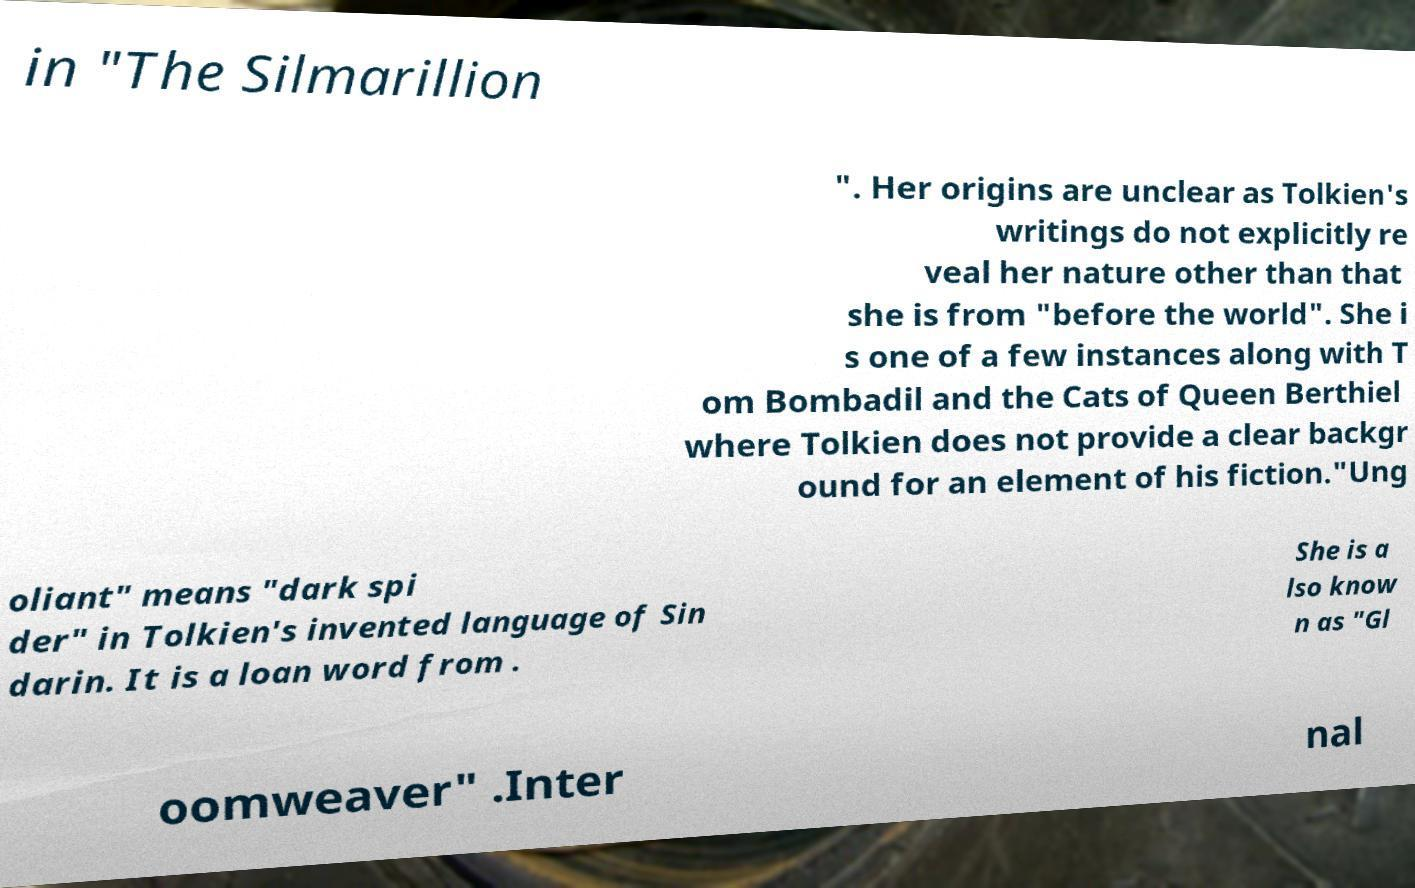Could you extract and type out the text from this image? in "The Silmarillion ". Her origins are unclear as Tolkien's writings do not explicitly re veal her nature other than that she is from "before the world". She i s one of a few instances along with T om Bombadil and the Cats of Queen Berthiel where Tolkien does not provide a clear backgr ound for an element of his fiction."Ung oliant" means "dark spi der" in Tolkien's invented language of Sin darin. It is a loan word from . She is a lso know n as "Gl oomweaver" .Inter nal 